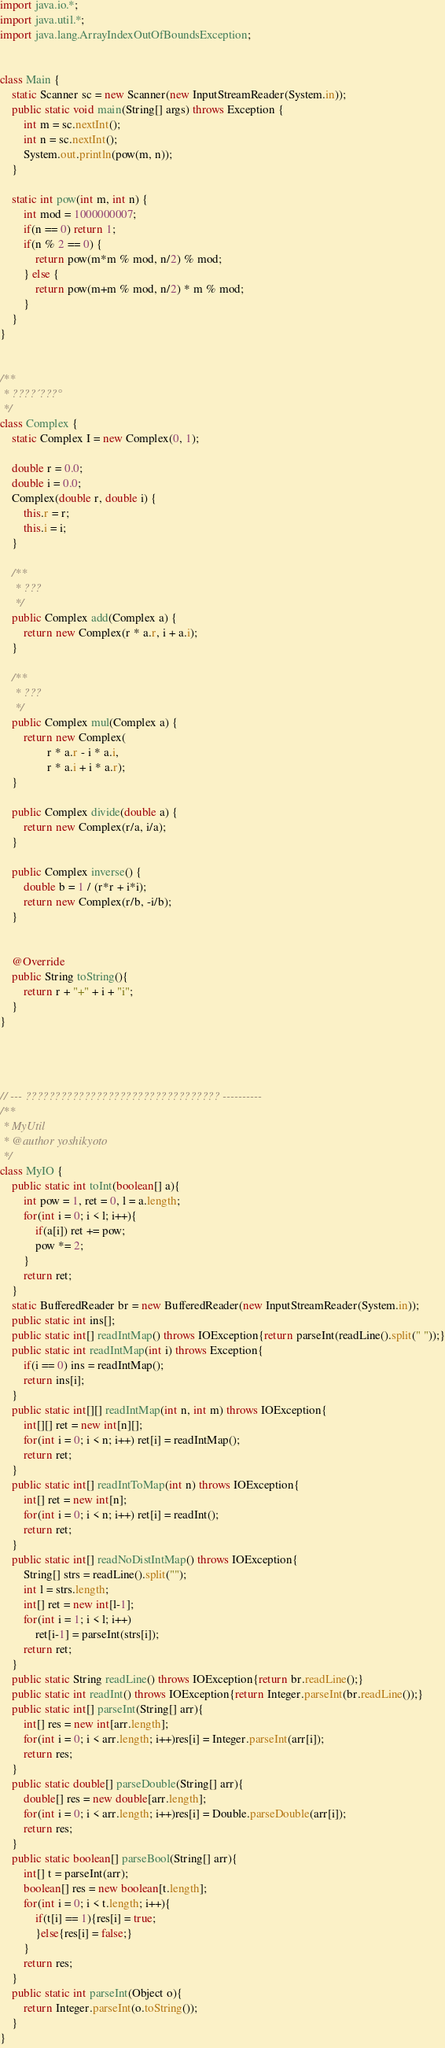<code> <loc_0><loc_0><loc_500><loc_500><_Java_>import java.io.*;
import java.util.*;
import java.lang.ArrayIndexOutOfBoundsException;


class Main {
	static Scanner sc = new Scanner(new InputStreamReader(System.in));
	public static void main(String[] args) throws Exception {
		int m = sc.nextInt();
		int n = sc.nextInt();
		System.out.println(pow(m, n));
	}
	
	static int pow(int m, int n) {
		int mod = 1000000007;
		if(n == 0) return 1;
		if(n % 2 == 0) {
			return pow(m*m % mod, n/2) % mod;
		} else {
			return pow(m+m % mod, n/2) * m % mod;
		}
	}
}


/**
 * ????´???°
 */
class Complex {
	static Complex I = new Complex(0, 1);
	
	double r = 0.0;
	double i = 0.0;
	Complex(double r, double i) {
		this.r = r;
		this.i = i;
	}
	
	/**
	 * ???
	 */
	public Complex add(Complex a) {
		return new Complex(r * a.r, i + a.i);
	}
	
	/**
	 * ???
	 */
	public Complex mul(Complex a) {
		return new Complex(
				r * a.r - i * a.i,
				r * a.i + i * a.r);
	}
	
	public Complex divide(double a) {
		return new Complex(r/a, i/a);
	}
	
	public Complex inverse() {
		double b = 1 / (r*r + i*i);
		return new Complex(r/b, -i/b);
	}
	    

	@Override
	public String toString(){
		return r + "+" + i + "i";
	}
}




// --- ????????????????????????????????? ----------
/**
 * MyUtil
 * @author yoshikyoto
 */
class MyIO {
	public static int toInt(boolean[] a){
		int pow = 1, ret = 0, l = a.length;
		for(int i = 0; i < l; i++){
			if(a[i]) ret += pow;
			pow *= 2;
		}
		return ret;
	}
	static BufferedReader br = new BufferedReader(new InputStreamReader(System.in));
	public static int ins[];
	public static int[] readIntMap() throws IOException{return parseInt(readLine().split(" "));}
	public static int readIntMap(int i) throws Exception{
		if(i == 0) ins = readIntMap();
		return ins[i];
	}
	public static int[][] readIntMap(int n, int m) throws IOException{
		int[][] ret = new int[n][];
		for(int i = 0; i < n; i++) ret[i] = readIntMap();
		return ret;
	}
	public static int[] readIntToMap(int n) throws IOException{
		int[] ret = new int[n];
		for(int i = 0; i < n; i++) ret[i] = readInt();
		return ret;
	}
	public static int[] readNoDistIntMap() throws IOException{
		String[] strs = readLine().split("");
		int l = strs.length;
		int[] ret = new int[l-1];
		for(int i = 1; i < l; i++)
			ret[i-1] = parseInt(strs[i]);
		return ret;
	}
	public static String readLine() throws IOException{return br.readLine();}
	public static int readInt() throws IOException{return Integer.parseInt(br.readLine());}
	public static int[] parseInt(String[] arr){
		int[] res = new int[arr.length];
		for(int i = 0; i < arr.length; i++)res[i] = Integer.parseInt(arr[i]);
		return res;
	}
	public static double[] parseDouble(String[] arr){
		double[] res = new double[arr.length];
		for(int i = 0; i < arr.length; i++)res[i] = Double.parseDouble(arr[i]);
		return res;
	}
	public static boolean[] parseBool(String[] arr){
		int[] t = parseInt(arr);
		boolean[] res = new boolean[t.length];
		for(int i = 0; i < t.length; i++){
			if(t[i] == 1){res[i] = true;
			}else{res[i] = false;}
		}
		return res;
	}
	public static int parseInt(Object o){
		return Integer.parseInt(o.toString());
	}
}</code> 